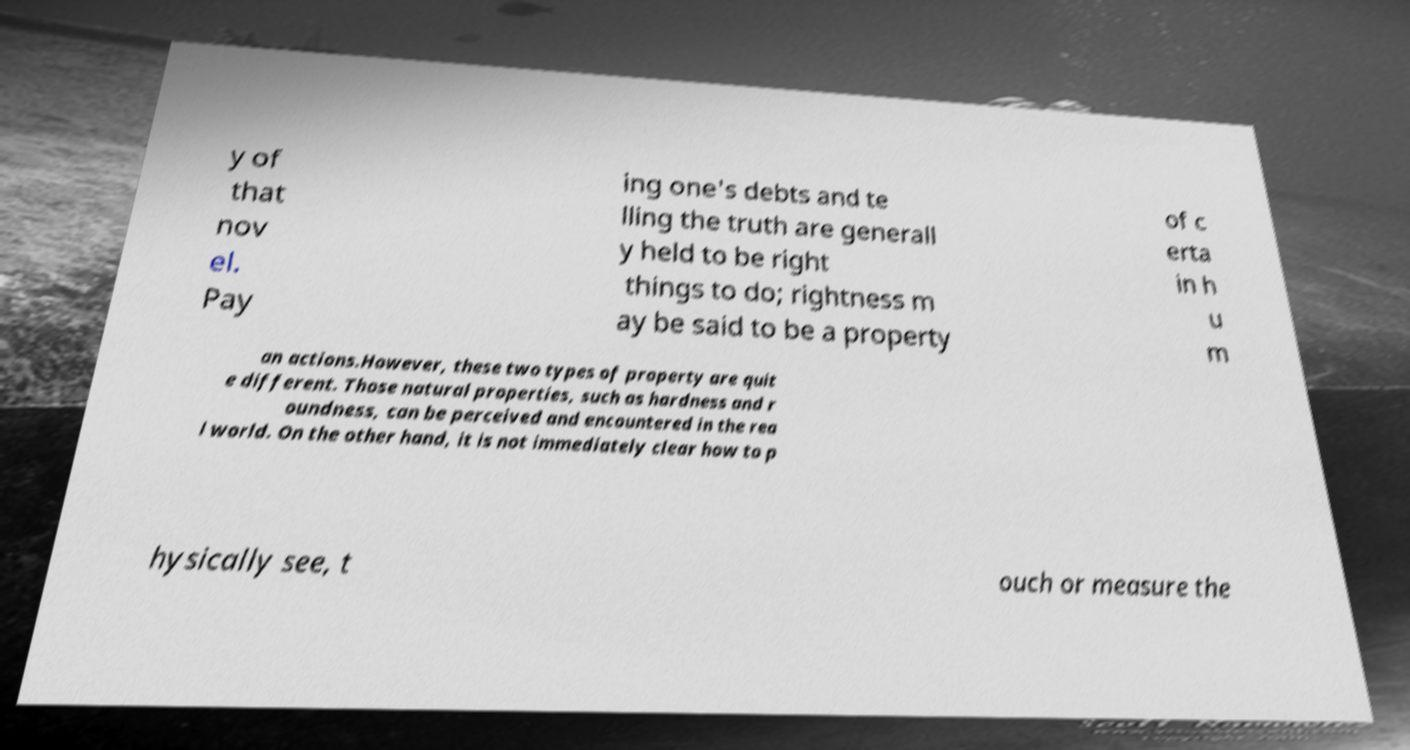Please read and relay the text visible in this image. What does it say? y of that nov el. Pay ing one's debts and te lling the truth are generall y held to be right things to do; rightness m ay be said to be a property of c erta in h u m an actions.However, these two types of property are quit e different. Those natural properties, such as hardness and r oundness, can be perceived and encountered in the rea l world. On the other hand, it is not immediately clear how to p hysically see, t ouch or measure the 